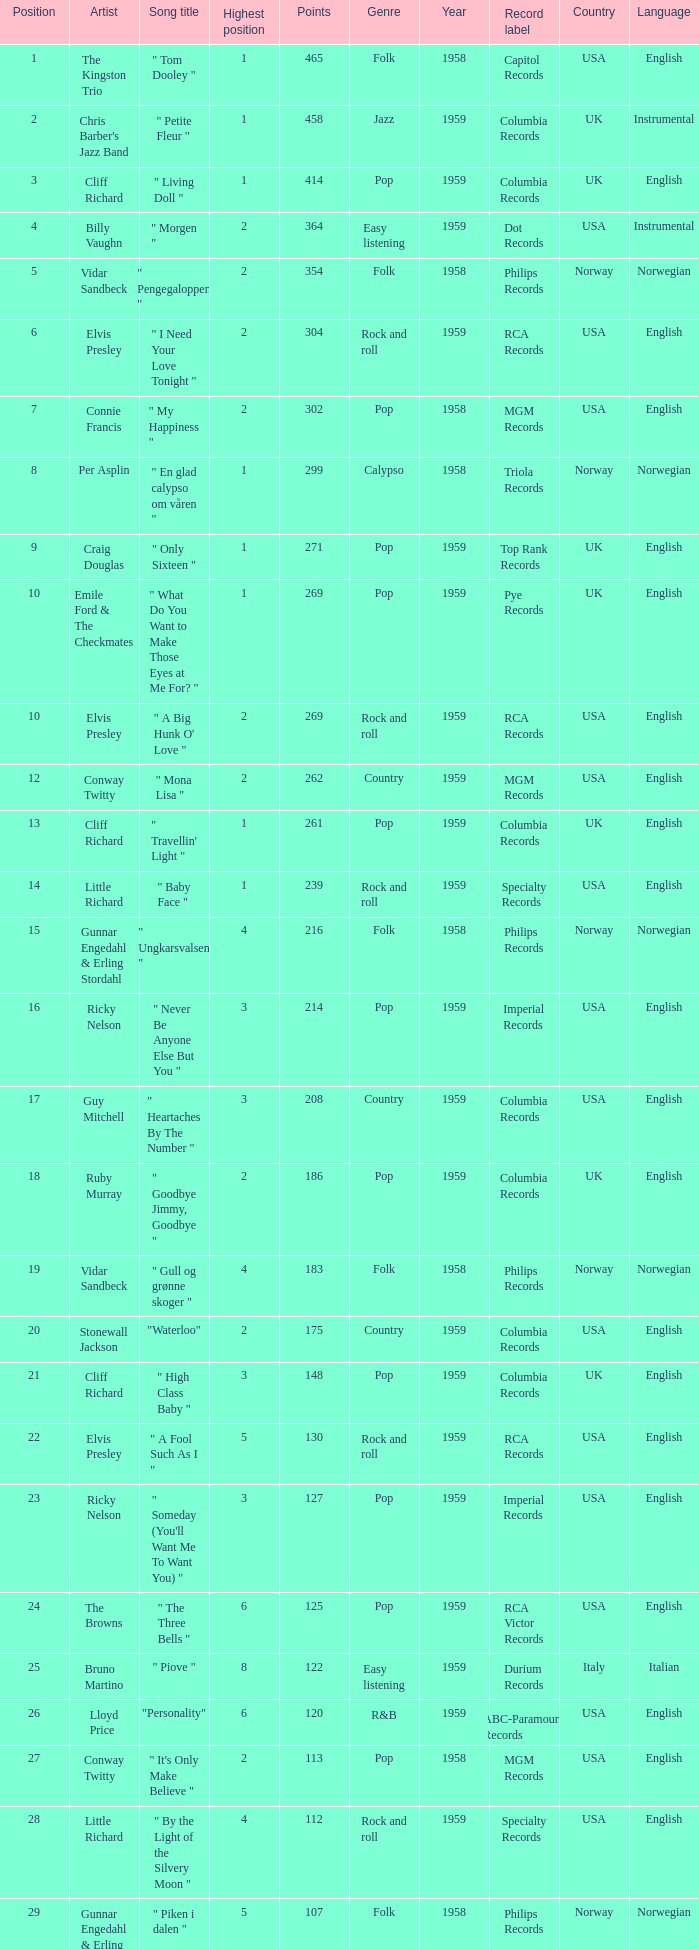What is the nme of the song performed by billy vaughn? " Morgen ". 